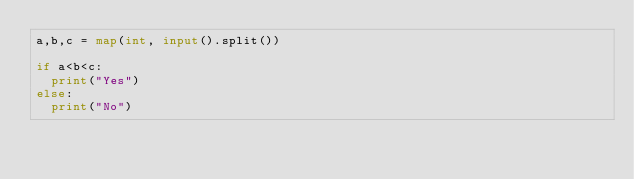<code> <loc_0><loc_0><loc_500><loc_500><_Python_>a,b,c = map(int, input().split())

if a<b<c:
  print("Yes")
else:
  print("No")
</code> 